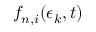Convert formula to latex. <formula><loc_0><loc_0><loc_500><loc_500>f _ { n , i } ( \epsilon _ { k } , t )</formula> 